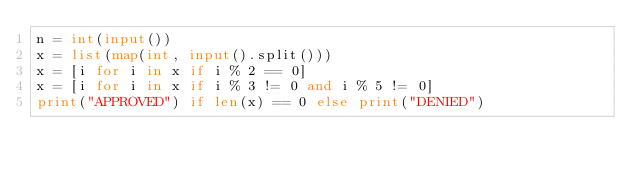<code> <loc_0><loc_0><loc_500><loc_500><_Python_>n = int(input())
x = list(map(int, input().split()))
x = [i for i in x if i % 2 == 0]
x = [i for i in x if i % 3 != 0 and i % 5 != 0]
print("APPROVED") if len(x) == 0 else print("DENIED")</code> 